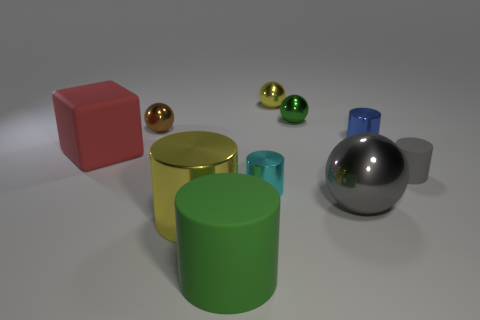Describe the texture and material appearance of the objects in the image. The image displays a variety of objects with different textures and material appearances. The large red block and the small gray cylinder have a matte finish, suggesting a metallic or stone-like material. The yellow and green cylinders exhibit a glossy, painted metal look, while the spheres have a reflective, smooth surface that seems metallic. 